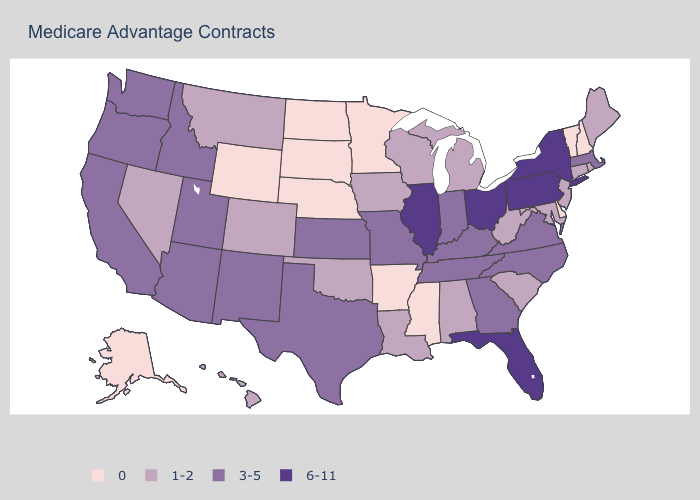Does Missouri have the same value as Tennessee?
Be succinct. Yes. How many symbols are there in the legend?
Answer briefly. 4. Name the states that have a value in the range 0?
Give a very brief answer. Alaska, Arkansas, Delaware, Minnesota, Mississippi, North Dakota, Nebraska, New Hampshire, South Dakota, Vermont, Wyoming. Name the states that have a value in the range 0?
Concise answer only. Alaska, Arkansas, Delaware, Minnesota, Mississippi, North Dakota, Nebraska, New Hampshire, South Dakota, Vermont, Wyoming. Which states hav the highest value in the West?
Be succinct. Arizona, California, Idaho, New Mexico, Oregon, Utah, Washington. What is the value of South Carolina?
Be succinct. 1-2. Does Washington have a lower value than Pennsylvania?
Give a very brief answer. Yes. What is the value of Massachusetts?
Concise answer only. 3-5. What is the value of Vermont?
Concise answer only. 0. What is the highest value in the USA?
Write a very short answer. 6-11. Does Wyoming have the highest value in the West?
Keep it brief. No. Name the states that have a value in the range 0?
Keep it brief. Alaska, Arkansas, Delaware, Minnesota, Mississippi, North Dakota, Nebraska, New Hampshire, South Dakota, Vermont, Wyoming. Name the states that have a value in the range 6-11?
Keep it brief. Florida, Illinois, New York, Ohio, Pennsylvania. Is the legend a continuous bar?
Quick response, please. No. What is the value of Maryland?
Short answer required. 1-2. 